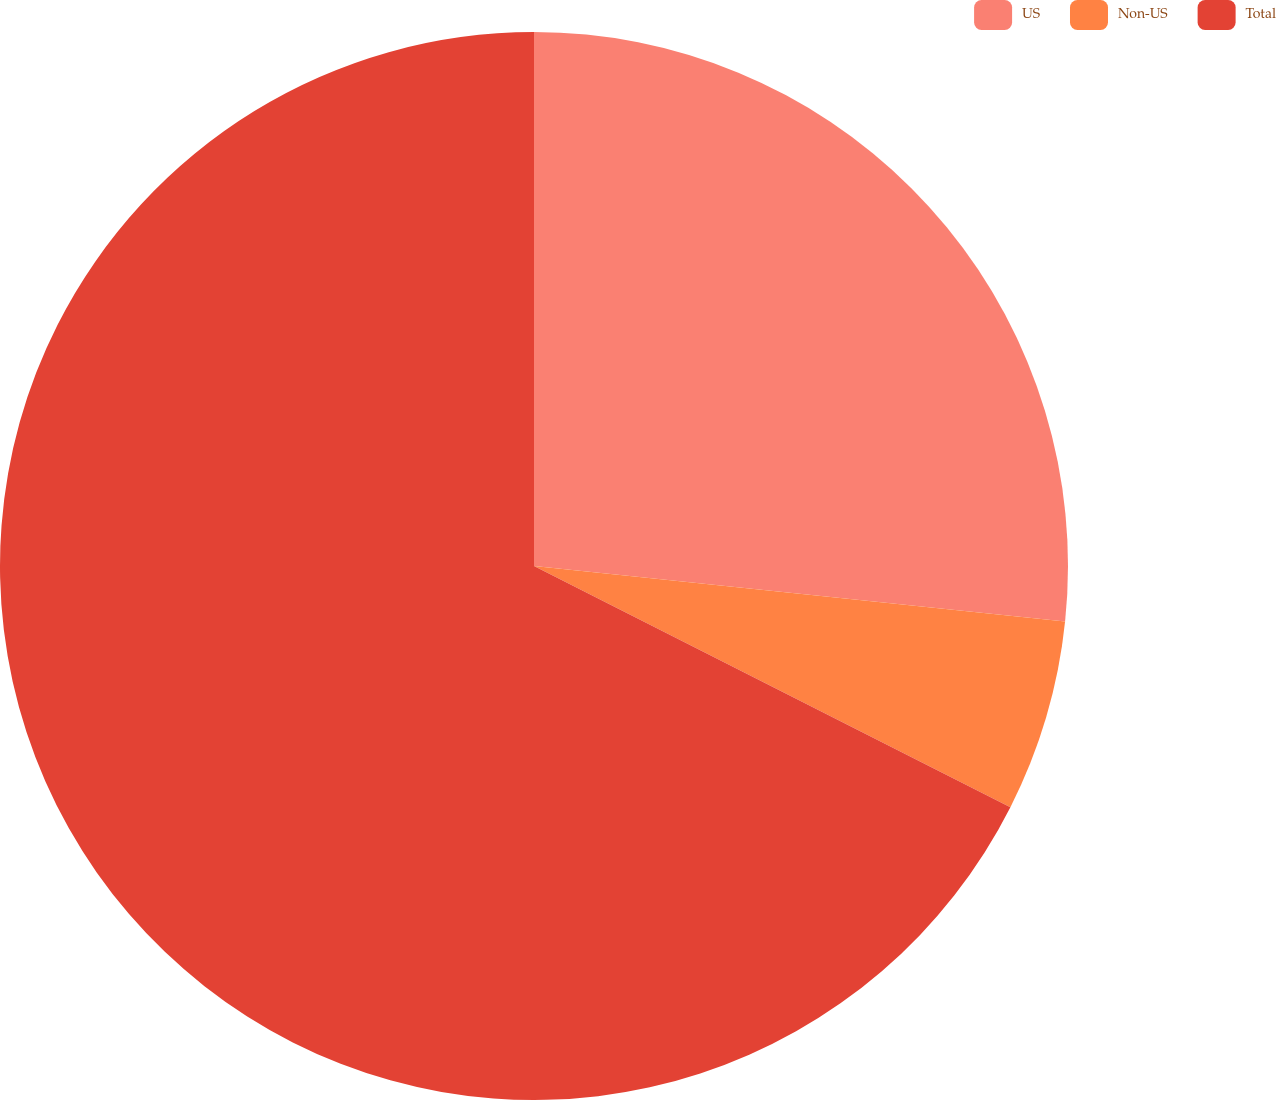<chart> <loc_0><loc_0><loc_500><loc_500><pie_chart><fcel>US<fcel>Non-US<fcel>Total<nl><fcel>26.66%<fcel>5.8%<fcel>67.54%<nl></chart> 